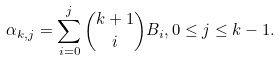Convert formula to latex. <formula><loc_0><loc_0><loc_500><loc_500>\alpha _ { k , j } = \sum _ { i = 0 } ^ { j } \binom { k + 1 } { i } B _ { i } , 0 \leq j \leq k - 1 .</formula> 